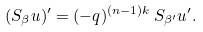Convert formula to latex. <formula><loc_0><loc_0><loc_500><loc_500>( S _ { \beta } u ) ^ { \prime } = ( - q ) ^ { ( n - 1 ) k } \, S _ { \beta ^ { \prime } } u ^ { \prime } .</formula> 